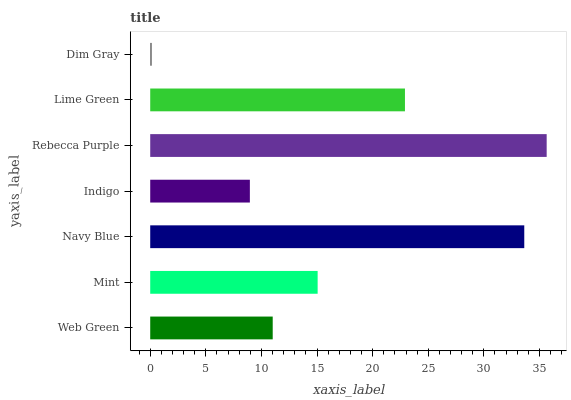Is Dim Gray the minimum?
Answer yes or no. Yes. Is Rebecca Purple the maximum?
Answer yes or no. Yes. Is Mint the minimum?
Answer yes or no. No. Is Mint the maximum?
Answer yes or no. No. Is Mint greater than Web Green?
Answer yes or no. Yes. Is Web Green less than Mint?
Answer yes or no. Yes. Is Web Green greater than Mint?
Answer yes or no. No. Is Mint less than Web Green?
Answer yes or no. No. Is Mint the high median?
Answer yes or no. Yes. Is Mint the low median?
Answer yes or no. Yes. Is Lime Green the high median?
Answer yes or no. No. Is Lime Green the low median?
Answer yes or no. No. 